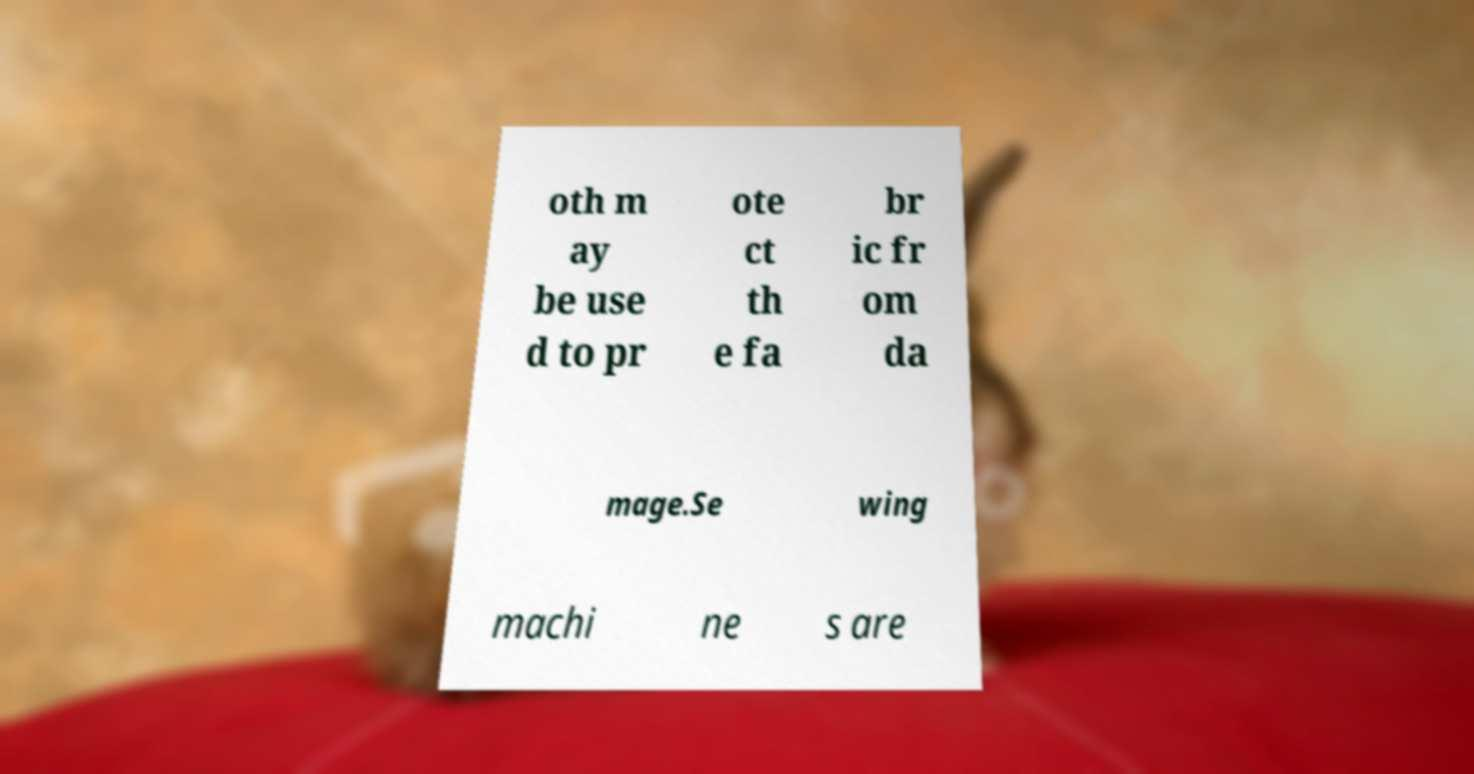Can you accurately transcribe the text from the provided image for me? oth m ay be use d to pr ote ct th e fa br ic fr om da mage.Se wing machi ne s are 